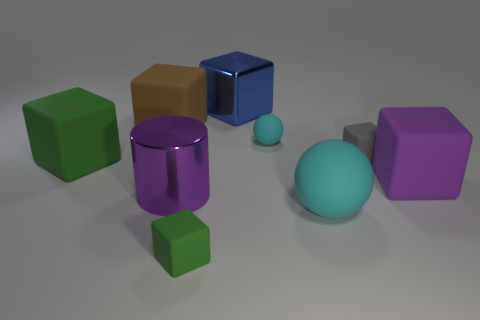Can you tell me the colors of the cube-shaped objects in the image? Certainly! There are four cube-shaped objects in total: one large green, one small green, one small yellow, and one small purple. 